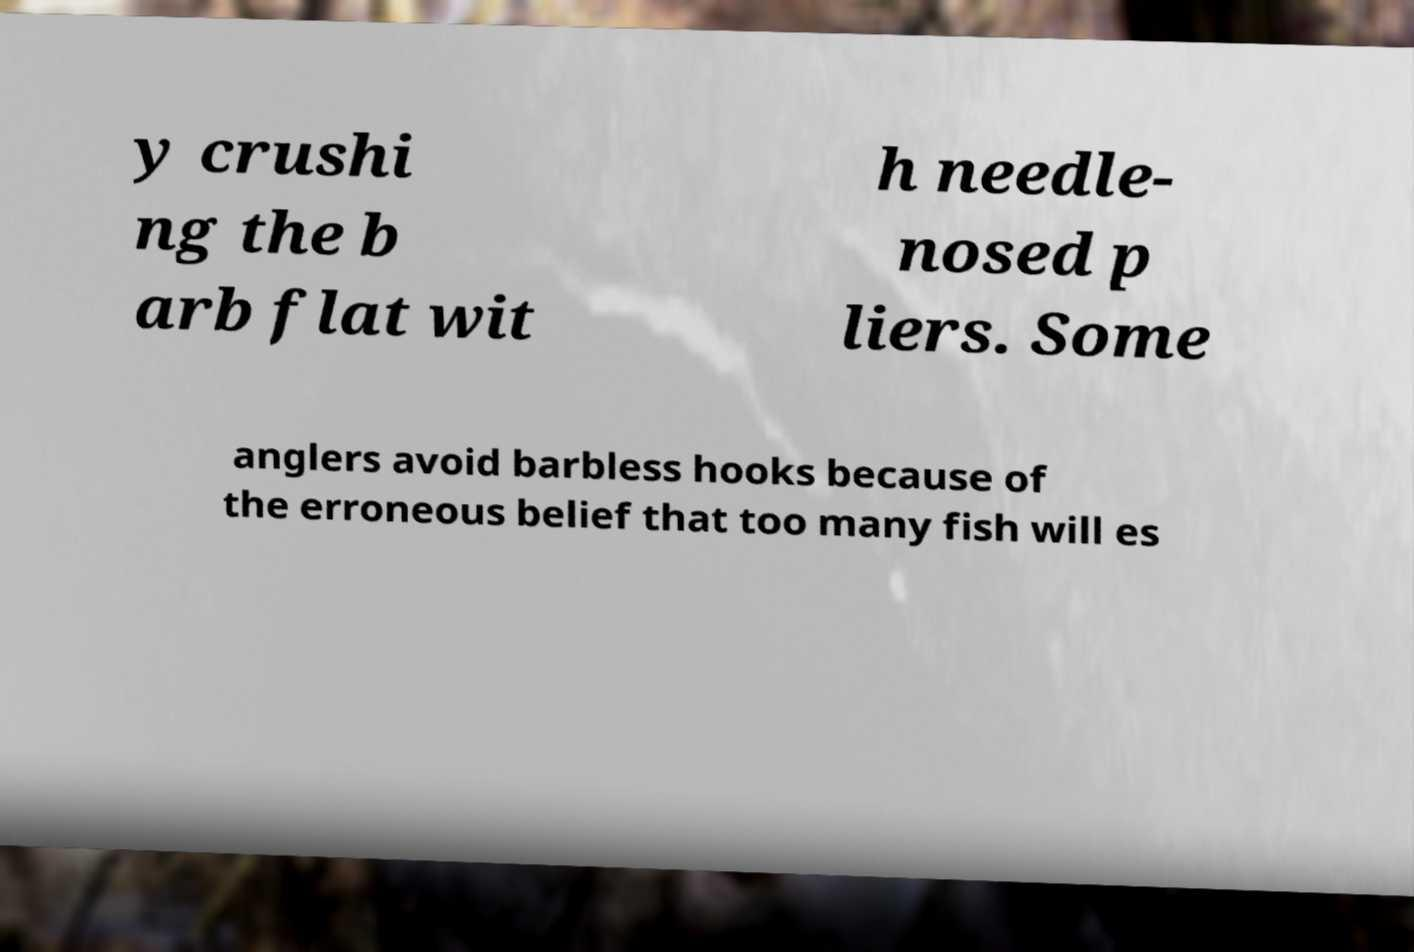What messages or text are displayed in this image? I need them in a readable, typed format. y crushi ng the b arb flat wit h needle- nosed p liers. Some anglers avoid barbless hooks because of the erroneous belief that too many fish will es 